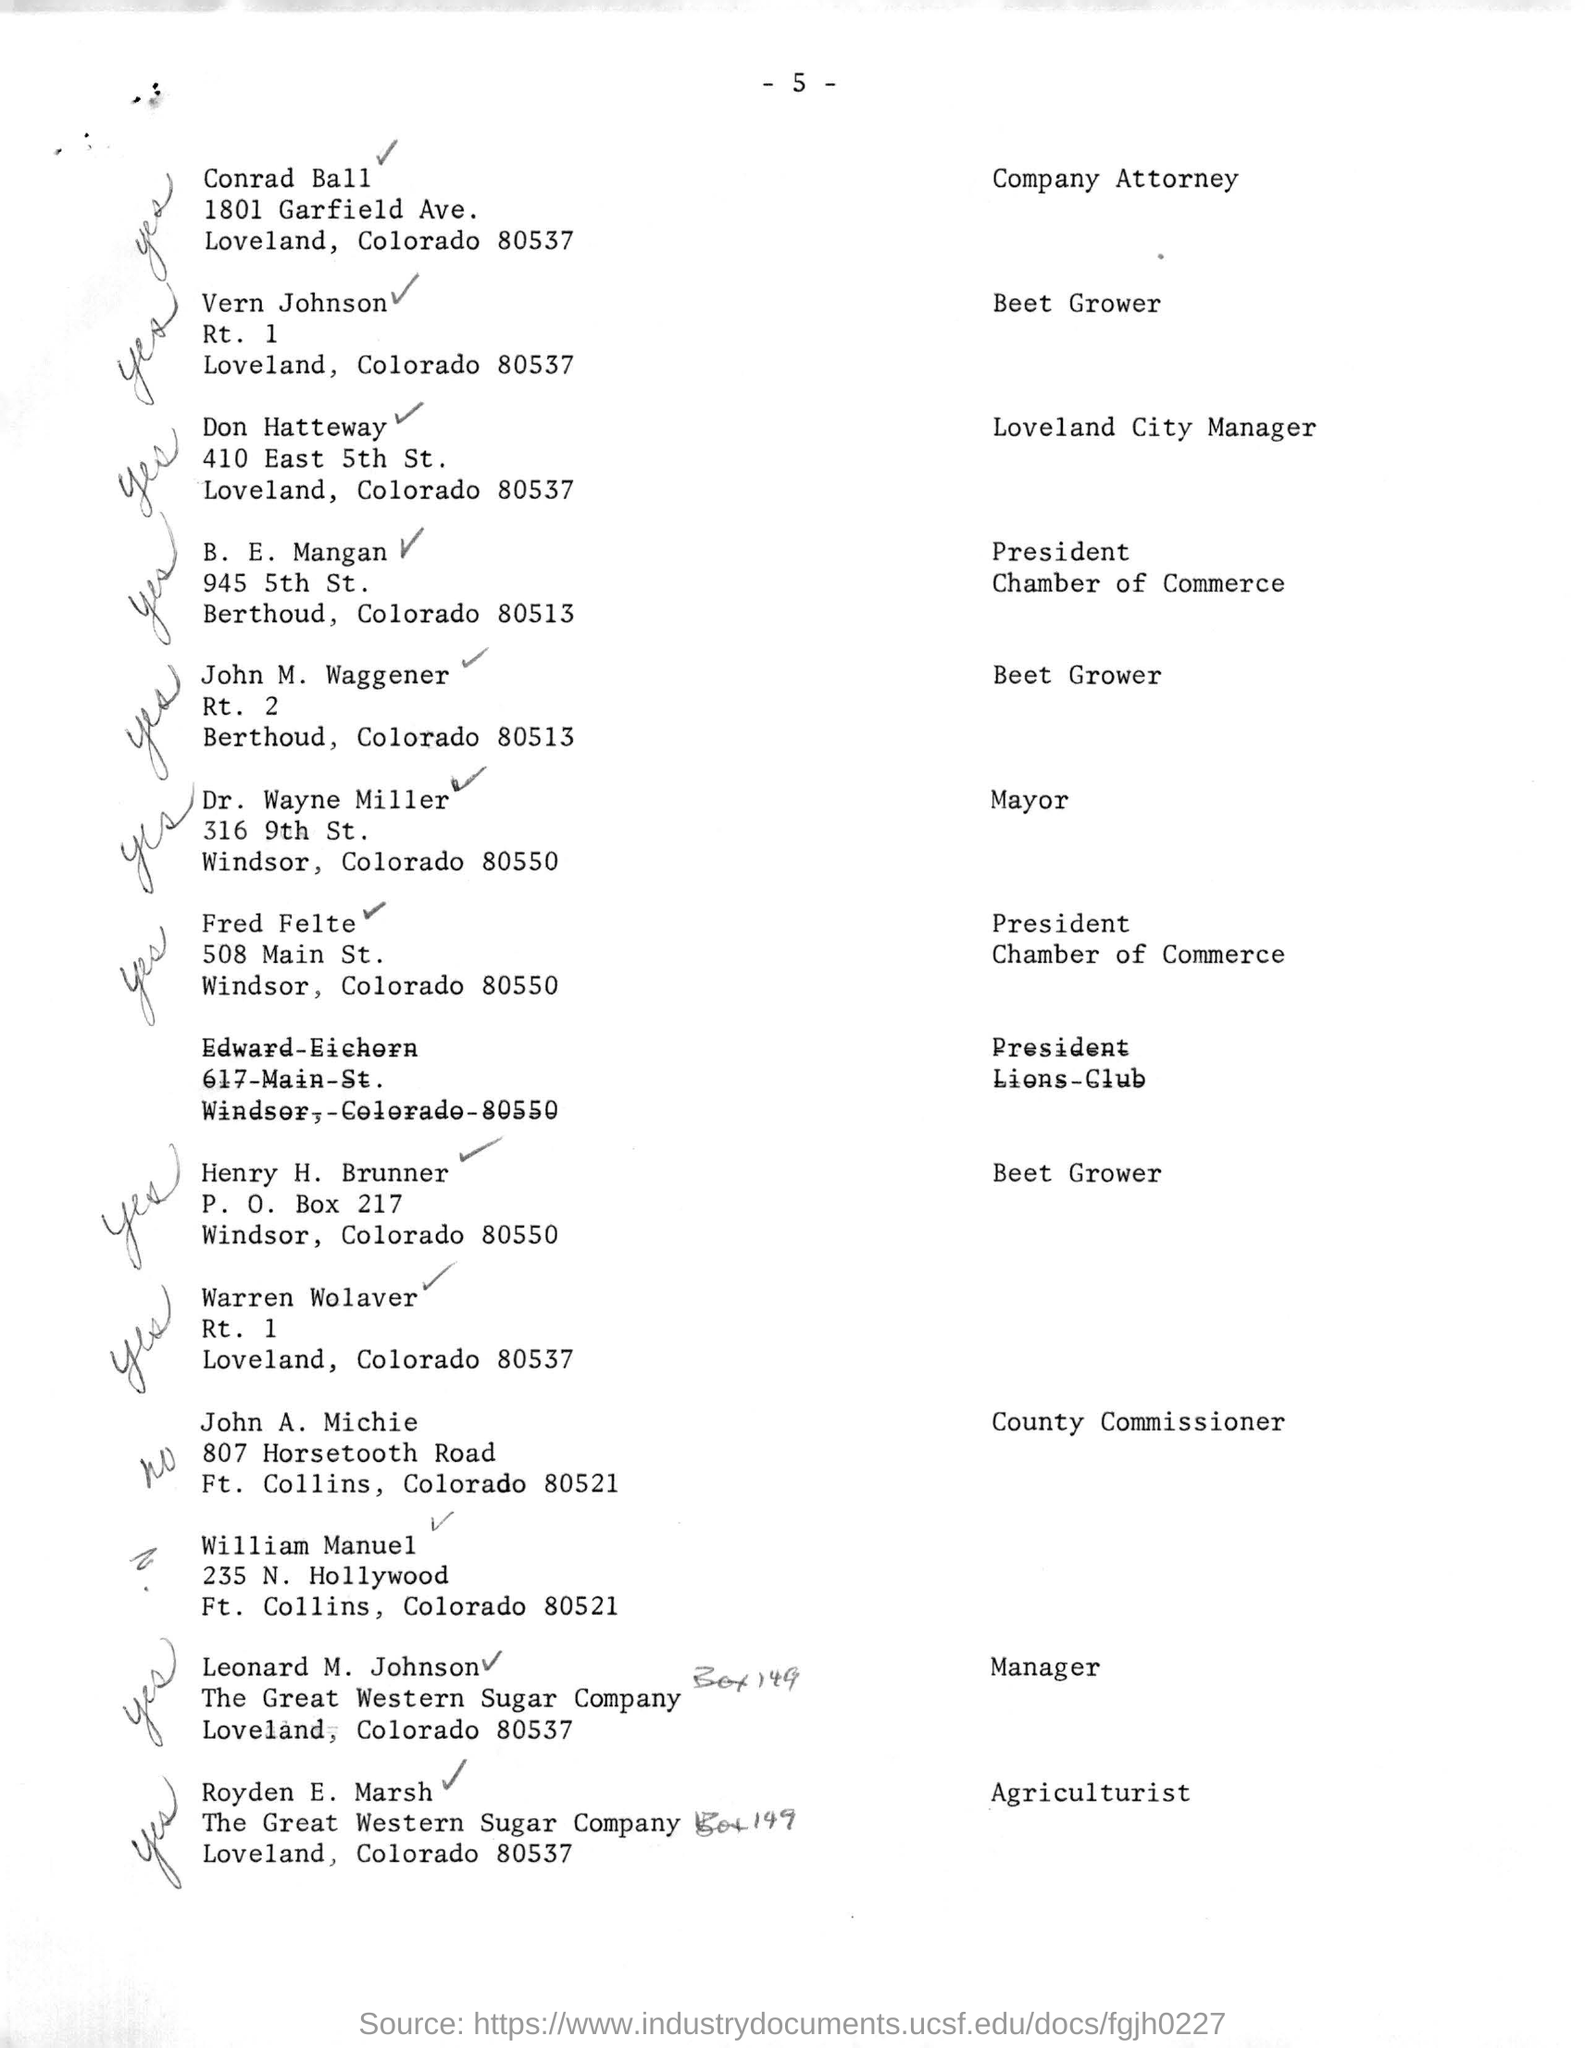Point out several critical features in this image. The attorney for the company is Conrad Ball. Royden E. Marsh is an agriculturist with a designation. Leonard M. Johnson's designation is that of a manager. The President of the Chamber of Commerce is Fred Felte. The page number mentioned in this document is 5. 